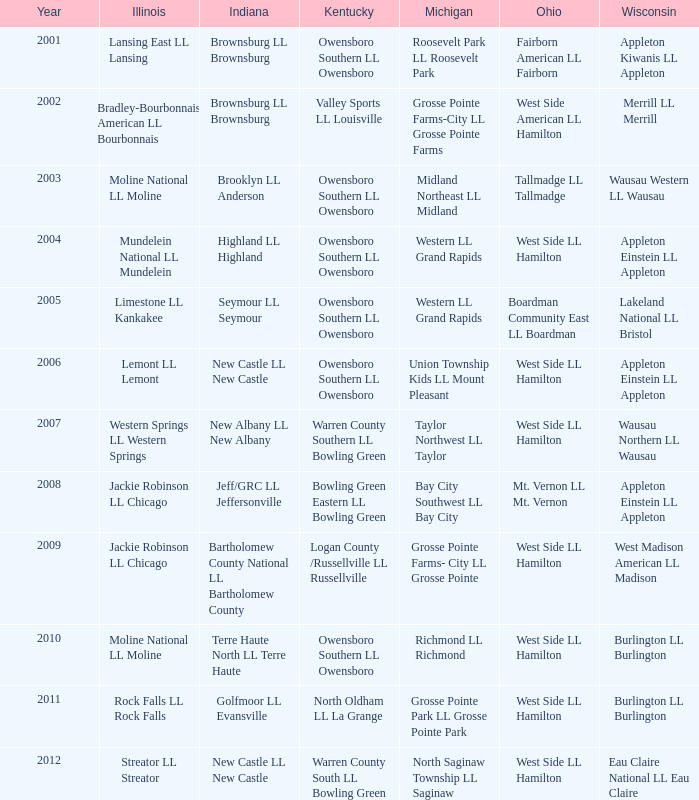When the indiana little league team was terre haute north ll terre haute, which team represented michigan? Richmond LL Richmond. 